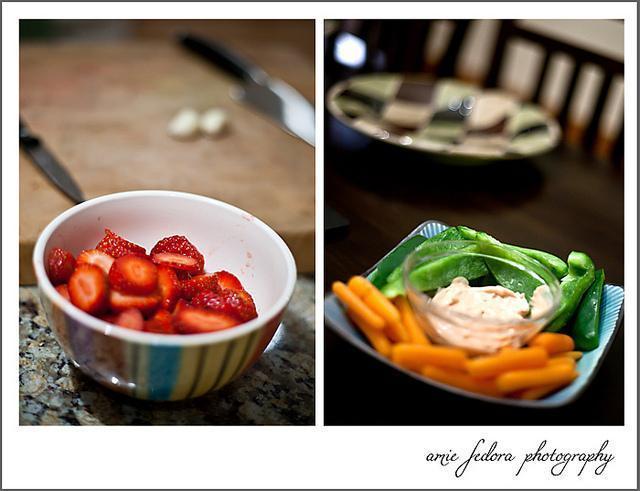How many bowls can be seen?
Give a very brief answer. 4. How many dining tables are in the picture?
Give a very brief answer. 2. 